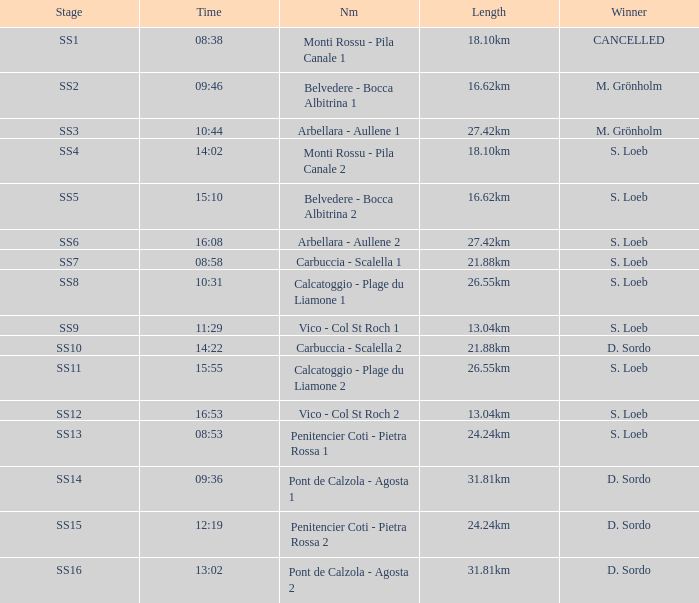What is the Name of the stage with a Length of 16.62km and Time of 15:10? Belvedere - Bocca Albitrina 2. 